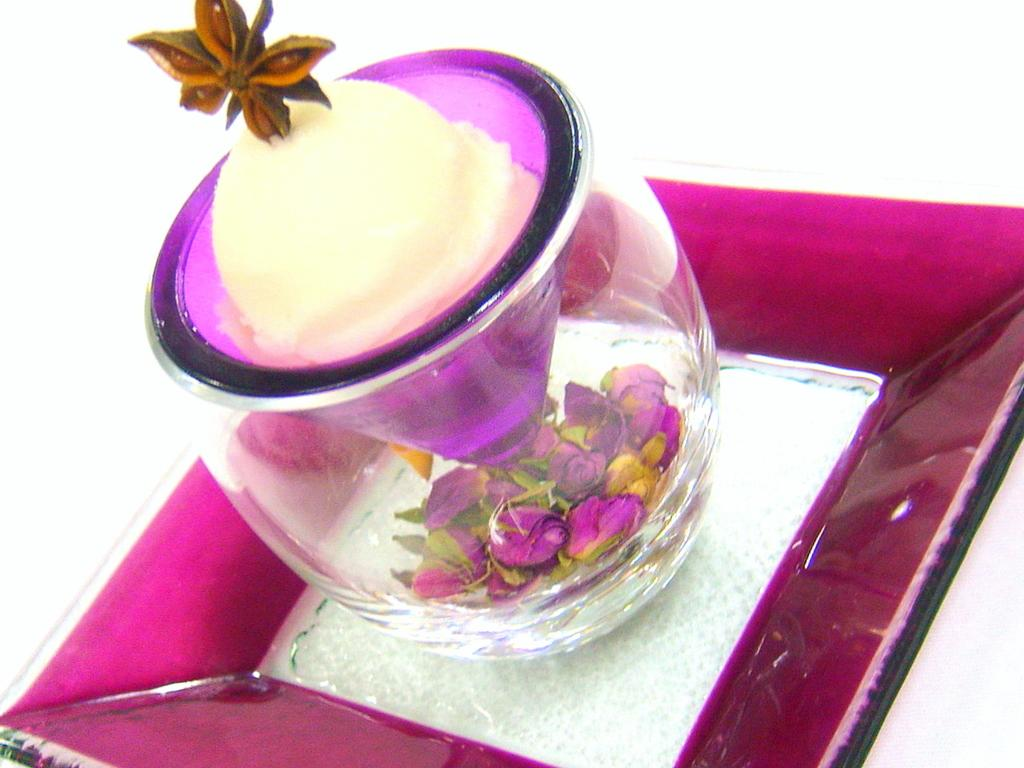What is present in the image that can hold a liquid or solid? There is a glass in the image. What is inside the glass? There is some eatable in the glass. Are there any decorative elements at the bottom of the glass? Yes, there are flowers at the bottom of the glass. What is the glass placed on in the image? The glass is kept on a plate. What type of advertisement can be seen on the plate in the image? There is no advertisement present in the image; it only features a glass with eatable and flowers at the bottom. 